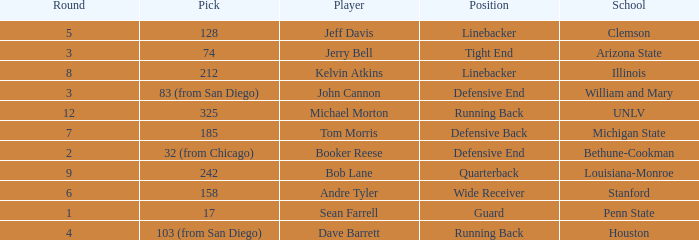Which school has a quarterback? Louisiana-Monroe. 